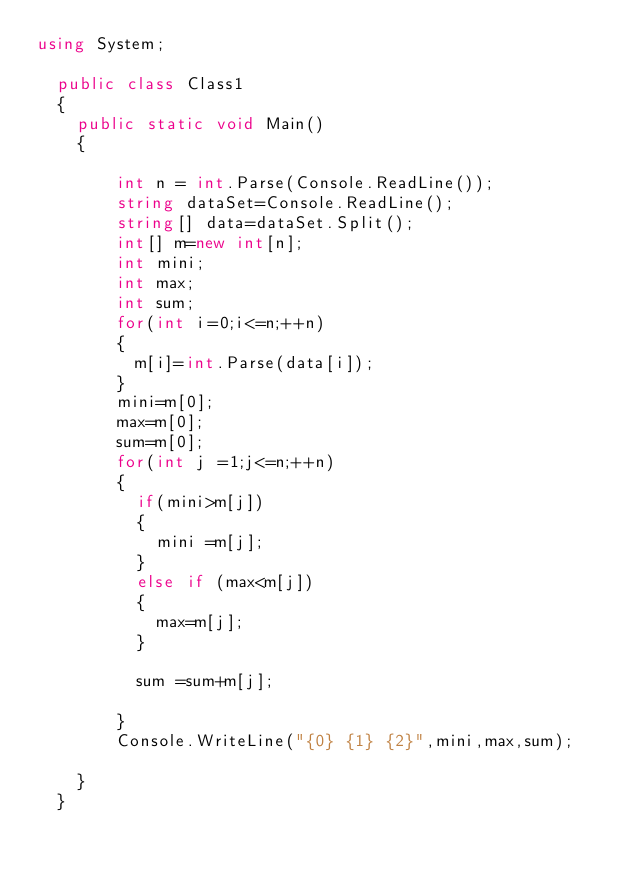<code> <loc_0><loc_0><loc_500><loc_500><_C#_>using System;

	public class Class1
	{
		public static void Main()
		{   
		
				int n = int.Parse(Console.ReadLine());
				string dataSet=Console.ReadLine();
				string[] data=dataSet.Split();
				int[] m=new int[n];
				int mini;
				int max;
				int sum;
				for(int i=0;i<=n;++n)
				{
					m[i]=int.Parse(data[i]);
				}
				mini=m[0];
				max=m[0];
				sum=m[0];
				for(int j =1;j<=n;++n)
				{
					if(mini>m[j])
					{
						mini =m[j];
					}
					else if (max<m[j])
					{
						max=m[j];					
					}
					
					sum =sum+m[j];
				
				}
				Console.WriteLine("{0} {1} {2}",mini,max,sum);
				
		}
	}
			    </code> 